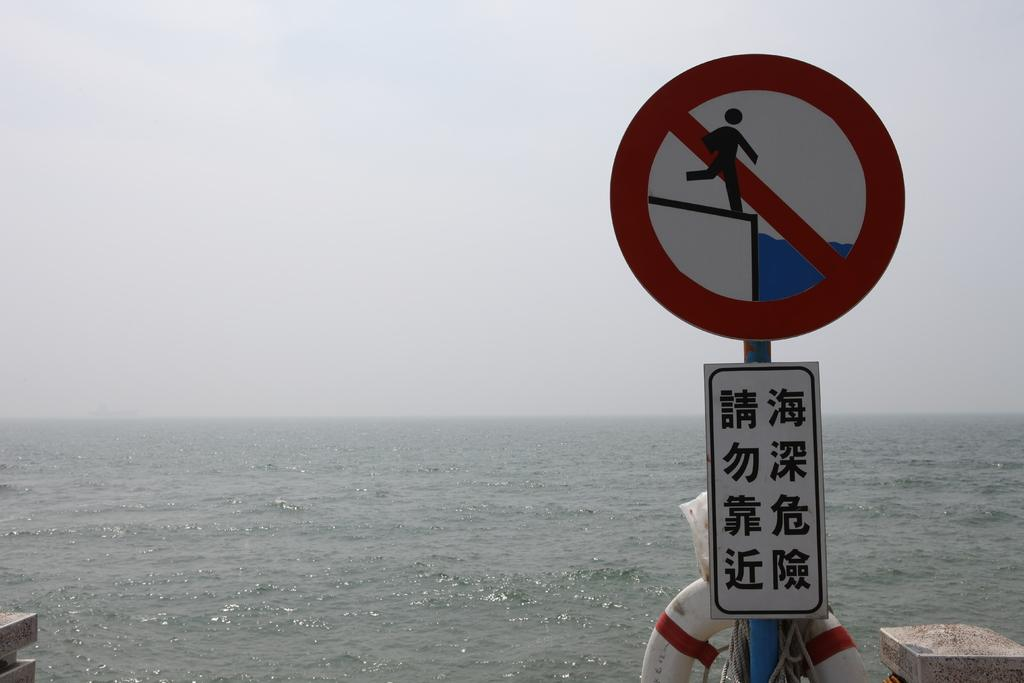What is on the pole in the image? There is a sign board on a pole in the image. What is tied with a rope in the image? A swimming tube is tied with a rope in the image. What can be seen in the background of the image? There is a large water body visible in the image. What is the condition of the sky in the image? The sky appears cloudy in the image. How many maids are present in the image? There are no maids present in the image. Can you spot a ladybug on the swimming tube? There is no ladybug visible on the swimming tube in the image. 